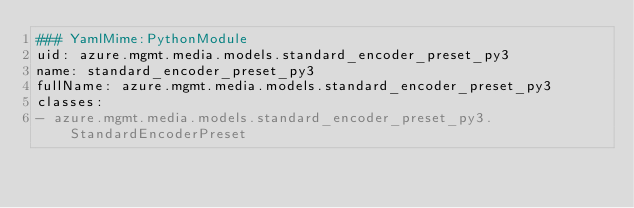Convert code to text. <code><loc_0><loc_0><loc_500><loc_500><_YAML_>### YamlMime:PythonModule
uid: azure.mgmt.media.models.standard_encoder_preset_py3
name: standard_encoder_preset_py3
fullName: azure.mgmt.media.models.standard_encoder_preset_py3
classes:
- azure.mgmt.media.models.standard_encoder_preset_py3.StandardEncoderPreset
</code> 